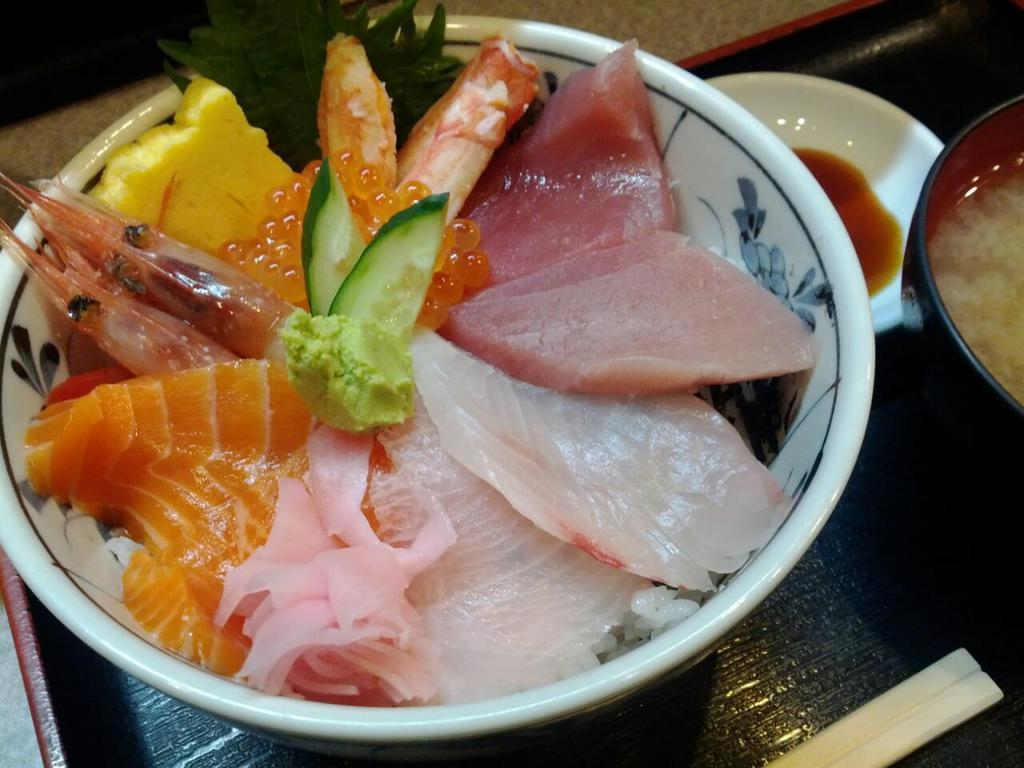What can be seen in the image? There are food items in the image. Where are the food items located? The food items are placed on a table. What type of industry is depicted in the image? There is no industry depicted in the image; it only shows food items placed on a table. How many pies are present in the image? The provided facts do not mention the presence of pies in the image. 